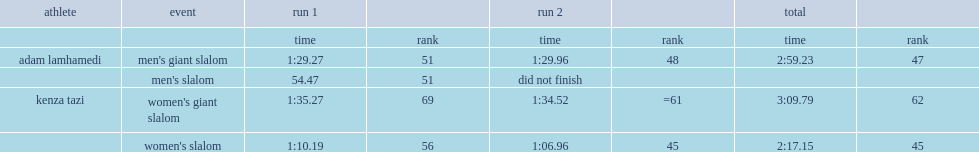What was the overall time of kenza tazi at the 2014 winter olympics? 2:17.15. 